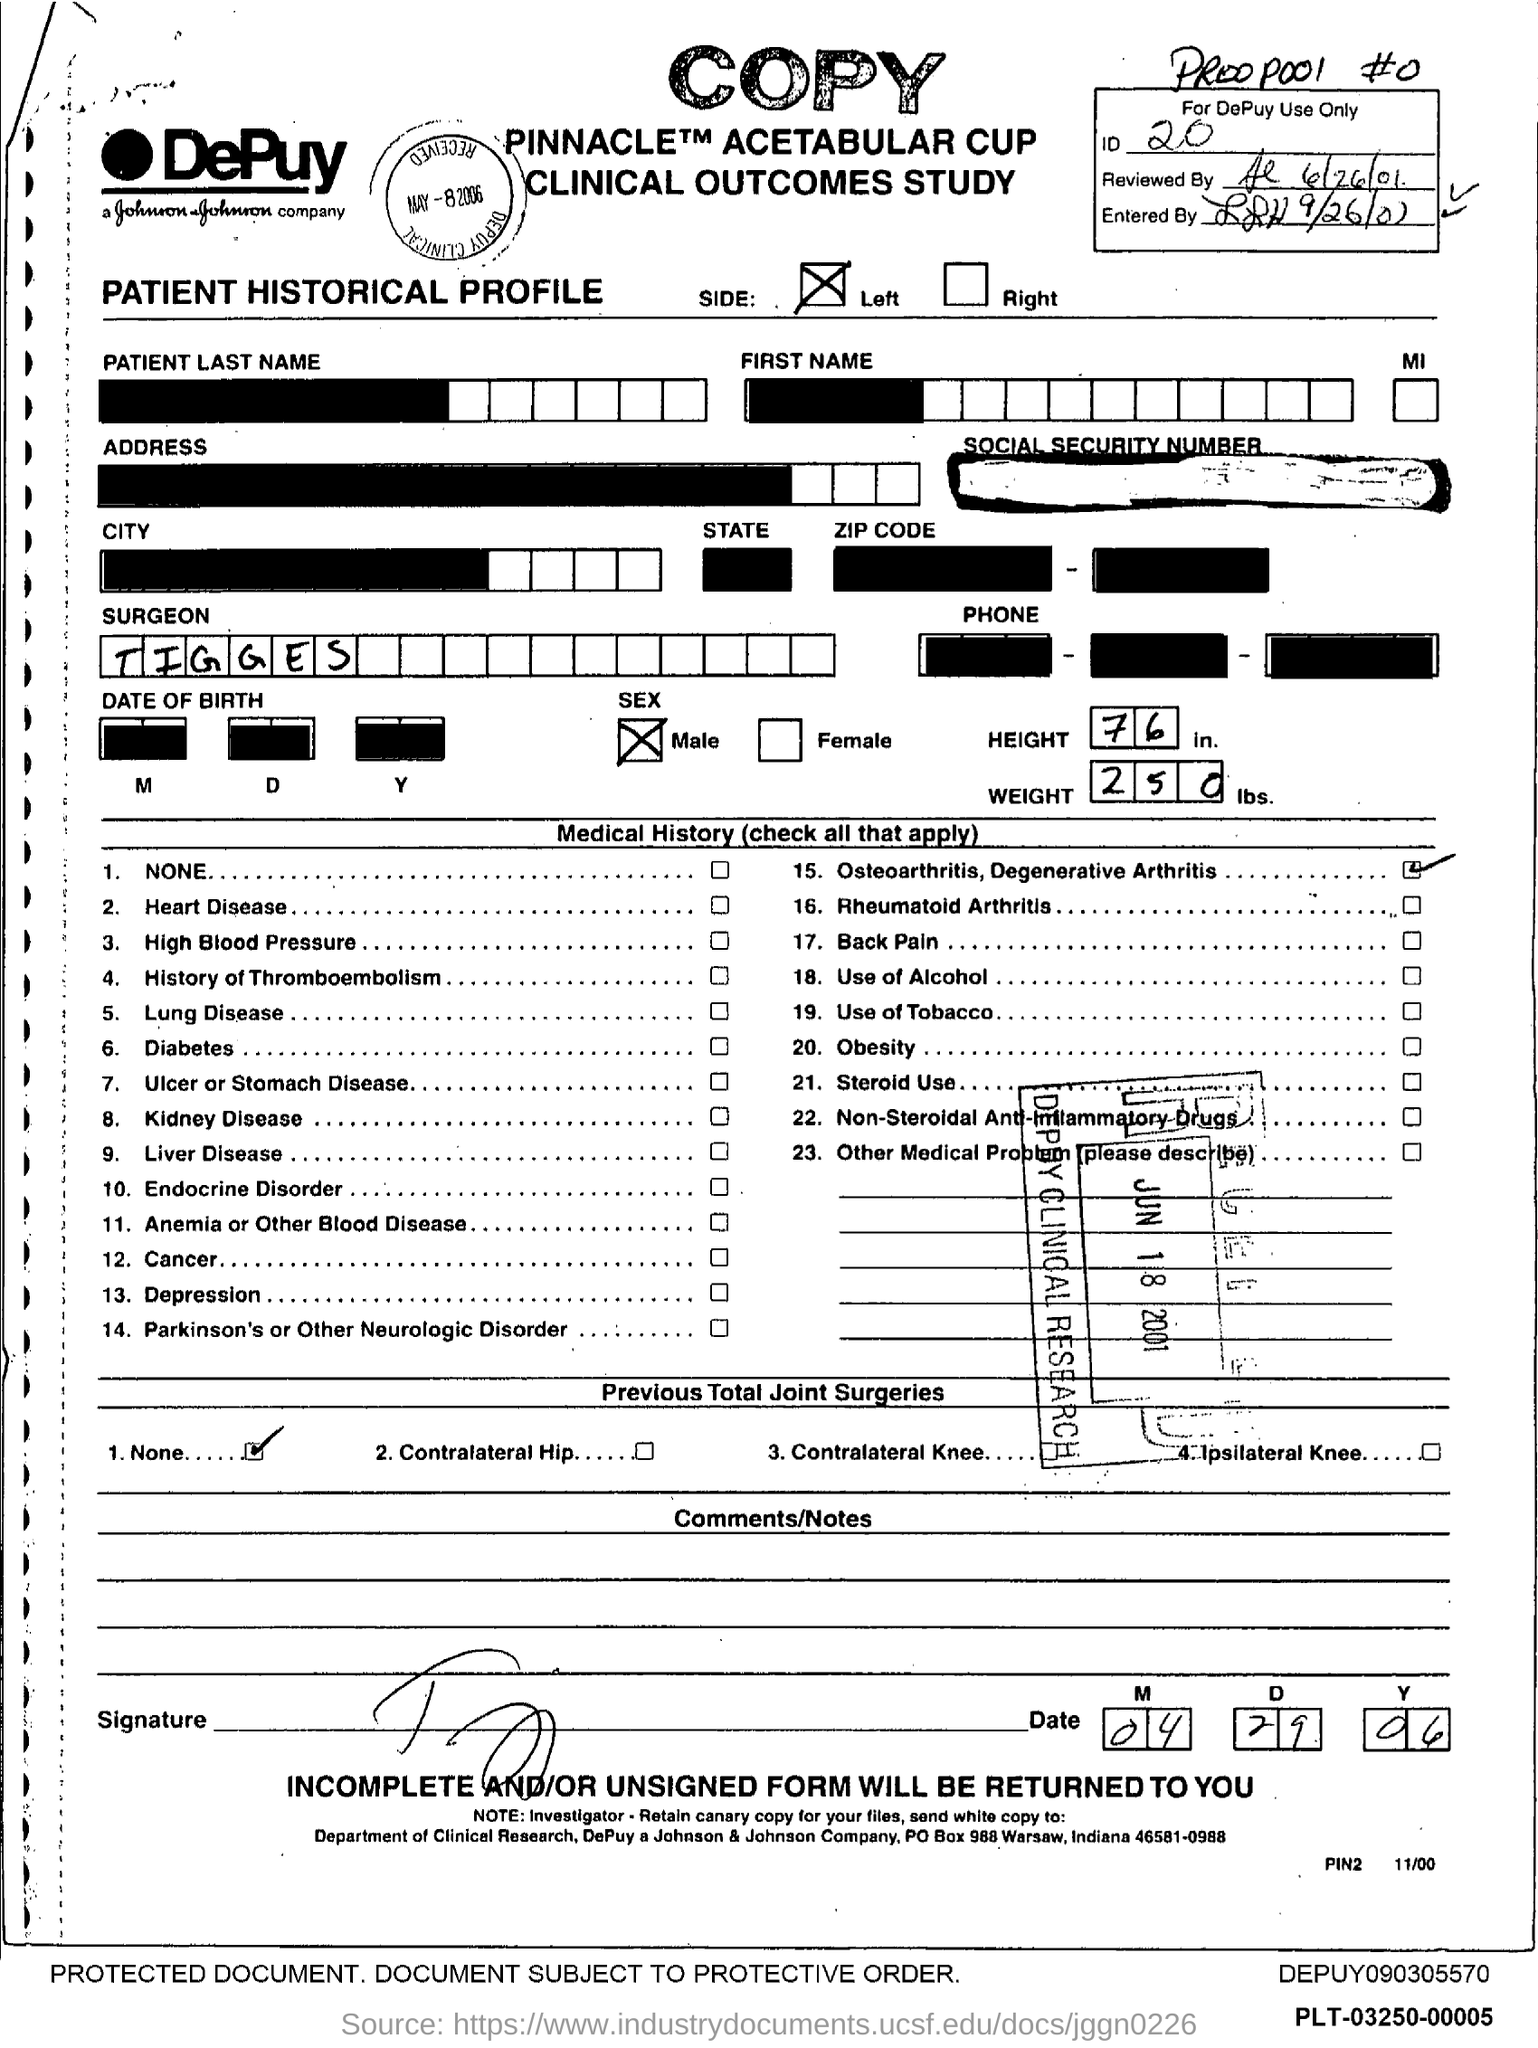List a handful of essential elements in this visual. The height is 76 inches. The speaker states that the weight is 250 pounds. The patient is requesting the name of the surgeon, whom they believe is named Tigges. 